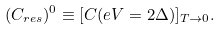<formula> <loc_0><loc_0><loc_500><loc_500>( C _ { r e s } ) ^ { 0 } \equiv [ C ( e V = 2 \Delta ) ] _ { T \rightarrow 0 } .</formula> 